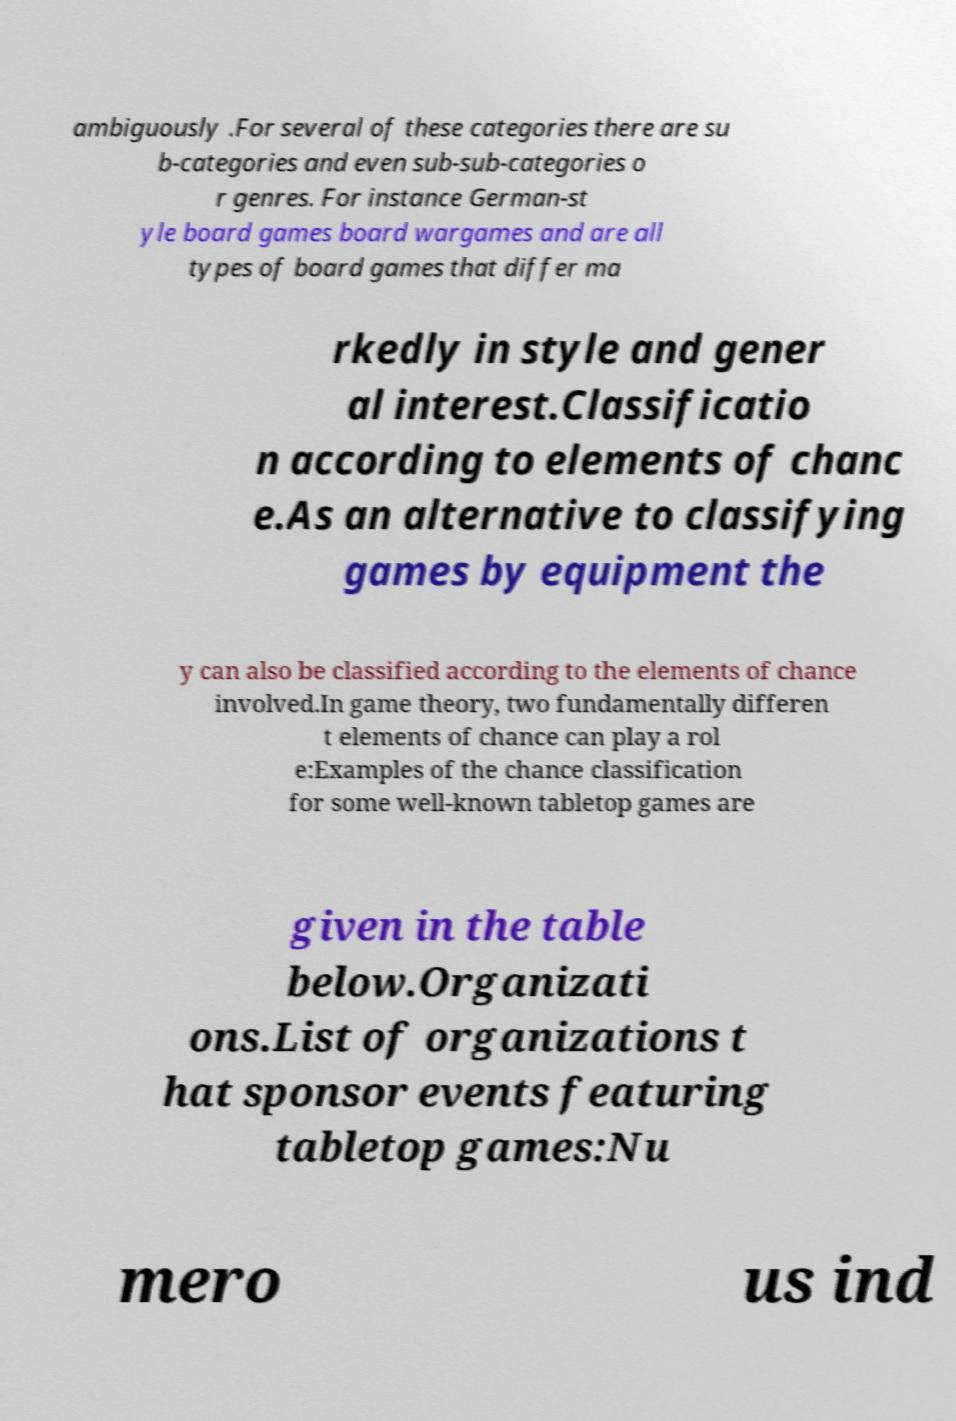For documentation purposes, I need the text within this image transcribed. Could you provide that? ambiguously .For several of these categories there are su b-categories and even sub-sub-categories o r genres. For instance German-st yle board games board wargames and are all types of board games that differ ma rkedly in style and gener al interest.Classificatio n according to elements of chanc e.As an alternative to classifying games by equipment the y can also be classified according to the elements of chance involved.In game theory, two fundamentally differen t elements of chance can play a rol e:Examples of the chance classification for some well-known tabletop games are given in the table below.Organizati ons.List of organizations t hat sponsor events featuring tabletop games:Nu mero us ind 